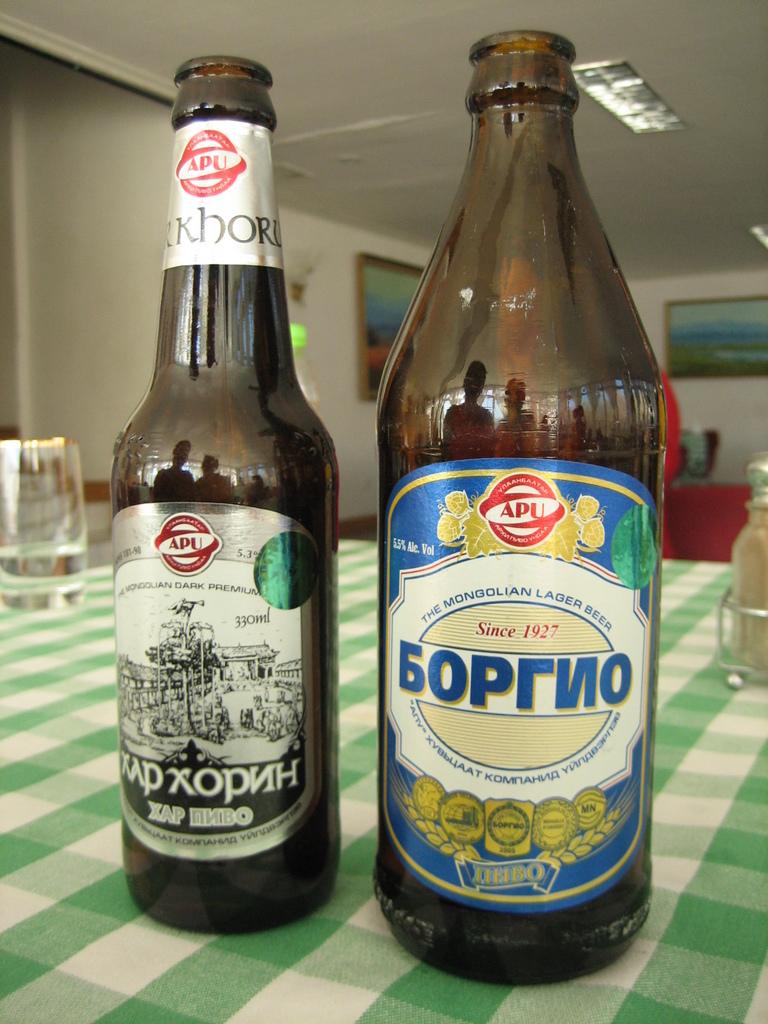What year was the beverage on the right started in?
Keep it short and to the point. 1927. What country is cited on the bottle to the right?
Offer a very short reply. Mongolia. 